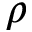Convert formula to latex. <formula><loc_0><loc_0><loc_500><loc_500>\rho</formula> 